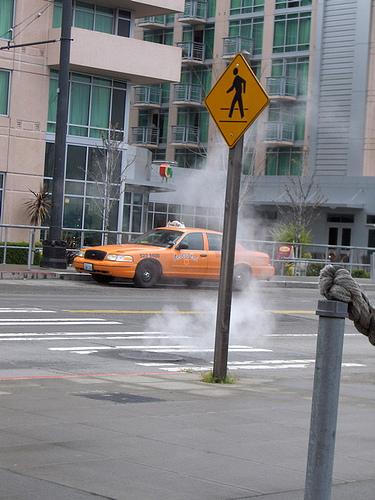<image>What is the store in the background? It is unknown what the store in the background is. It could be a hotel, apartment, bank or a coffee shop. What is the store in the background? I don't know what the store in the background is. It can be a closed one, hotel or apartment, clothing store, bank, coffee shop or apartment building. 